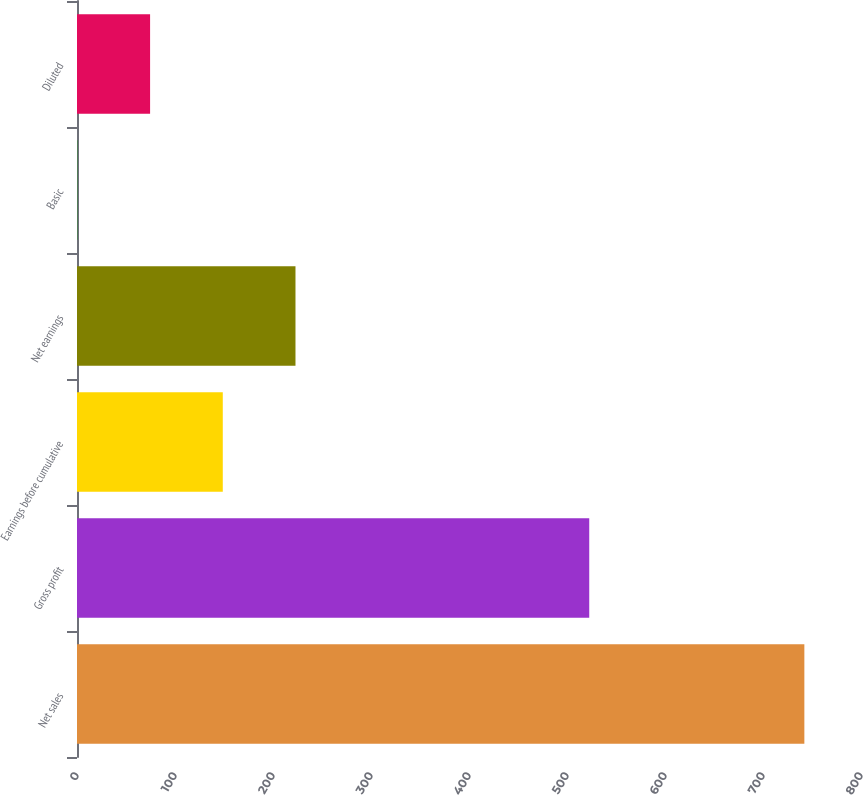Convert chart. <chart><loc_0><loc_0><loc_500><loc_500><bar_chart><fcel>Net sales<fcel>Gross profit<fcel>Earnings before cumulative<fcel>Net earnings<fcel>Basic<fcel>Diluted<nl><fcel>742.2<fcel>522.7<fcel>148.76<fcel>222.94<fcel>0.4<fcel>74.58<nl></chart> 